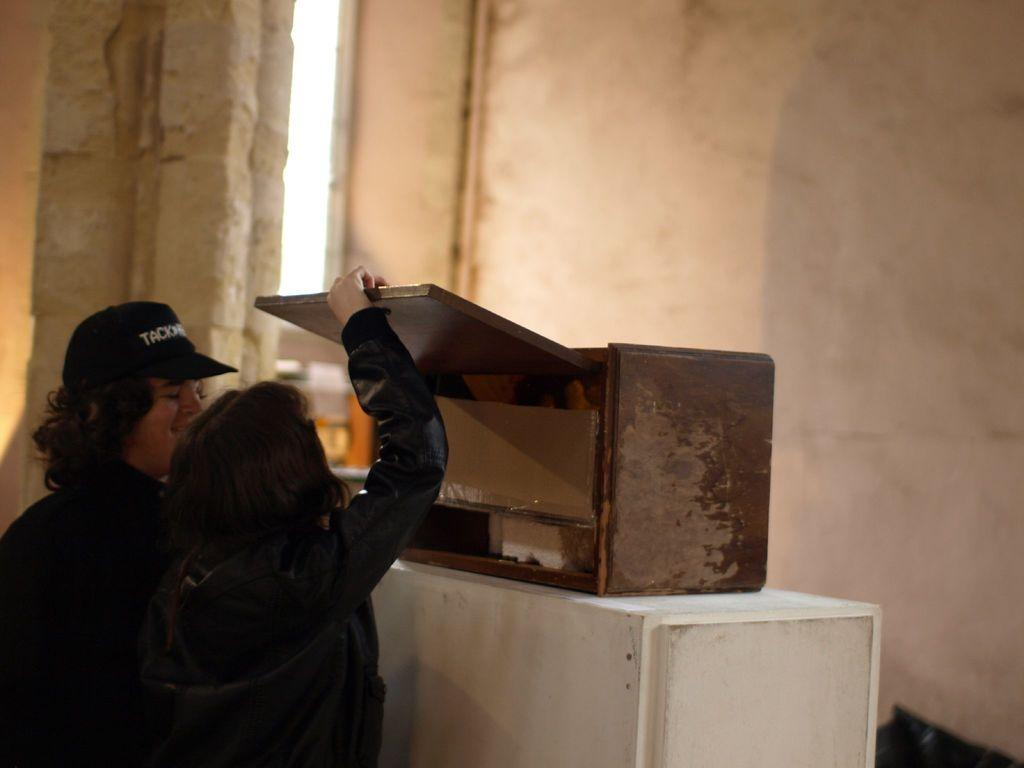How many people are present in the image? There are two people in the image. What is placed on the wall in the image? There is a wooden block placed on the wall in the image. What can be seen in the background of the image? There is a wall and the sky visible in the background of the image. What type of sponge can be seen floating in the sky in the image? There is no sponge visible in the image, and the sky is not occupied by any floating objects. 